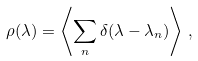Convert formula to latex. <formula><loc_0><loc_0><loc_500><loc_500>\rho ( \lambda ) = \left \langle \sum _ { n } \delta ( \lambda - \lambda _ { n } ) \right \rangle \, ,</formula> 